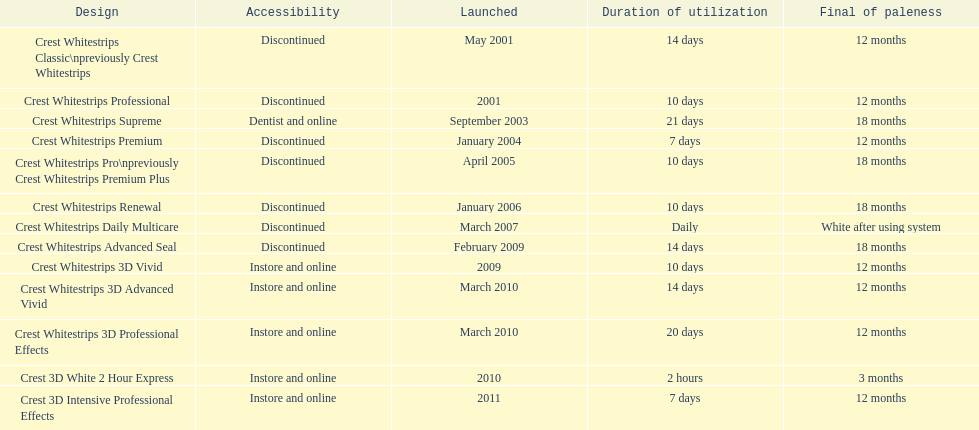Does the crest white strips classic last at least one year? Yes. 